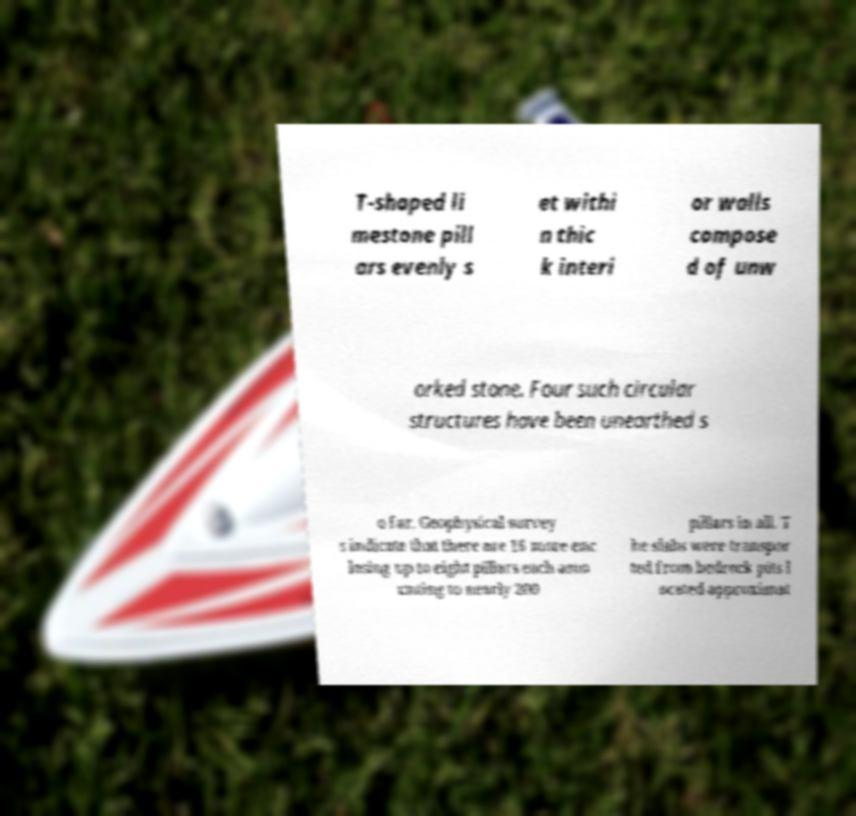Please read and relay the text visible in this image. What does it say? T-shaped li mestone pill ars evenly s et withi n thic k interi or walls compose d of unw orked stone. Four such circular structures have been unearthed s o far. Geophysical survey s indicate that there are 16 more enc losing up to eight pillars each amo unting to nearly 200 pillars in all. T he slabs were transpor ted from bedrock pits l ocated approximat 